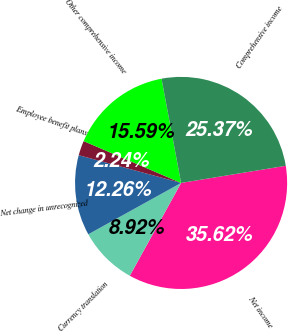Convert chart to OTSL. <chart><loc_0><loc_0><loc_500><loc_500><pie_chart><fcel>Net income<fcel>Currency translation<fcel>Net change in unrecognized<fcel>Employee benefit plans<fcel>Other comprehensive income<fcel>Comprehensive income<nl><fcel>35.62%<fcel>8.92%<fcel>12.26%<fcel>2.24%<fcel>15.59%<fcel>25.37%<nl></chart> 